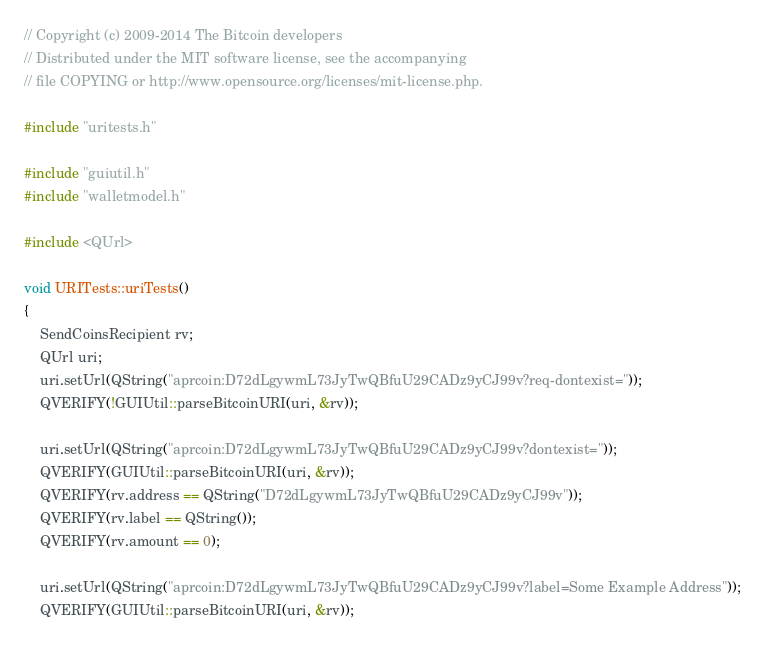Convert code to text. <code><loc_0><loc_0><loc_500><loc_500><_C++_>// Copyright (c) 2009-2014 The Bitcoin developers
// Distributed under the MIT software license, see the accompanying
// file COPYING or http://www.opensource.org/licenses/mit-license.php.

#include "uritests.h"

#include "guiutil.h"
#include "walletmodel.h"

#include <QUrl>

void URITests::uriTests()
{
    SendCoinsRecipient rv;
    QUrl uri;
    uri.setUrl(QString("aprcoin:D72dLgywmL73JyTwQBfuU29CADz9yCJ99v?req-dontexist="));
    QVERIFY(!GUIUtil::parseBitcoinURI(uri, &rv));

    uri.setUrl(QString("aprcoin:D72dLgywmL73JyTwQBfuU29CADz9yCJ99v?dontexist="));
    QVERIFY(GUIUtil::parseBitcoinURI(uri, &rv));
    QVERIFY(rv.address == QString("D72dLgywmL73JyTwQBfuU29CADz9yCJ99v"));
    QVERIFY(rv.label == QString());
    QVERIFY(rv.amount == 0);

    uri.setUrl(QString("aprcoin:D72dLgywmL73JyTwQBfuU29CADz9yCJ99v?label=Some Example Address"));
    QVERIFY(GUIUtil::parseBitcoinURI(uri, &rv));</code> 